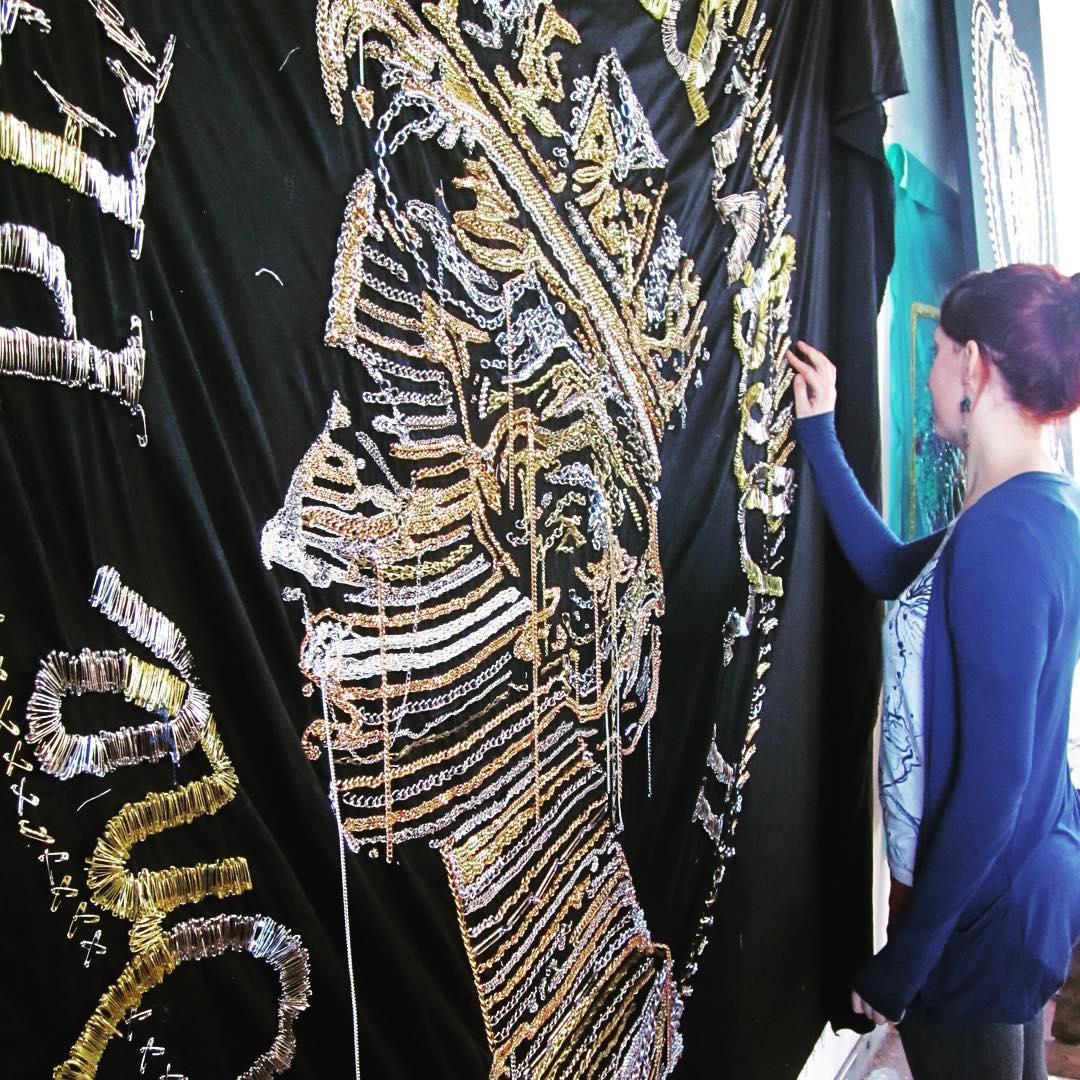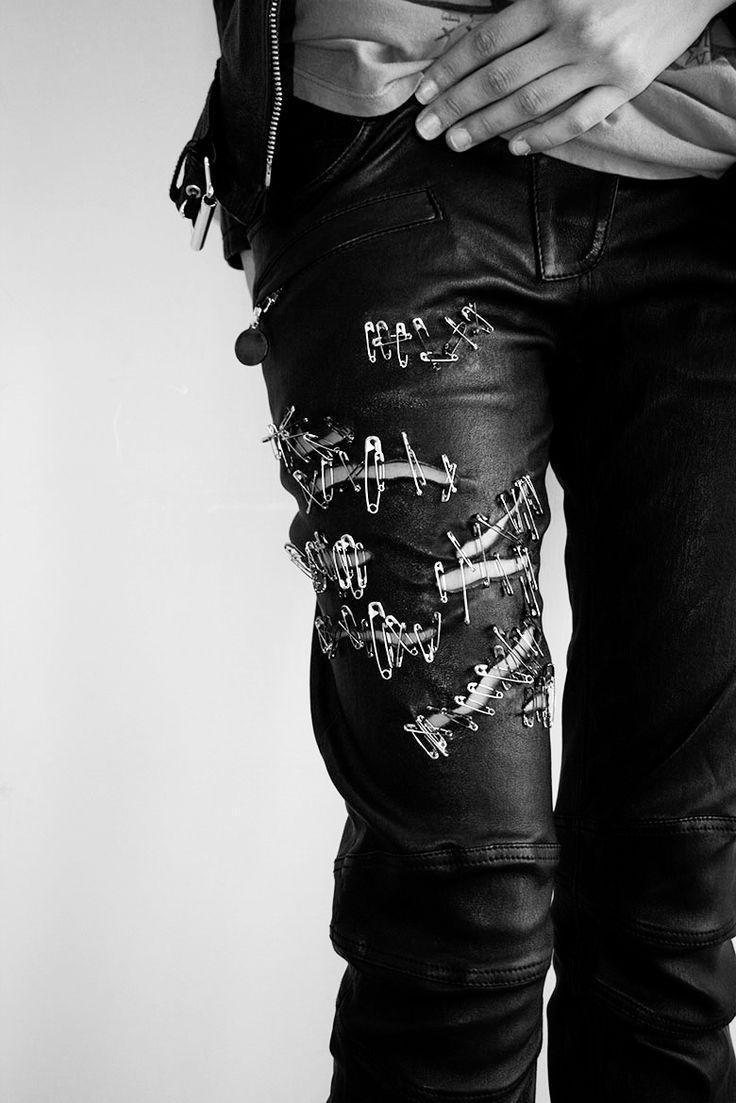The first image is the image on the left, the second image is the image on the right. Analyze the images presented: Is the assertion "The left image includes some depiction of safety pins, and the right image features at least one spike-studded leather jacket." valid? Answer yes or no. No. The first image is the image on the left, the second image is the image on the right. Examine the images to the left and right. Is the description "One of the images features a jacket held together with several safety pins." accurate? Answer yes or no. No. 